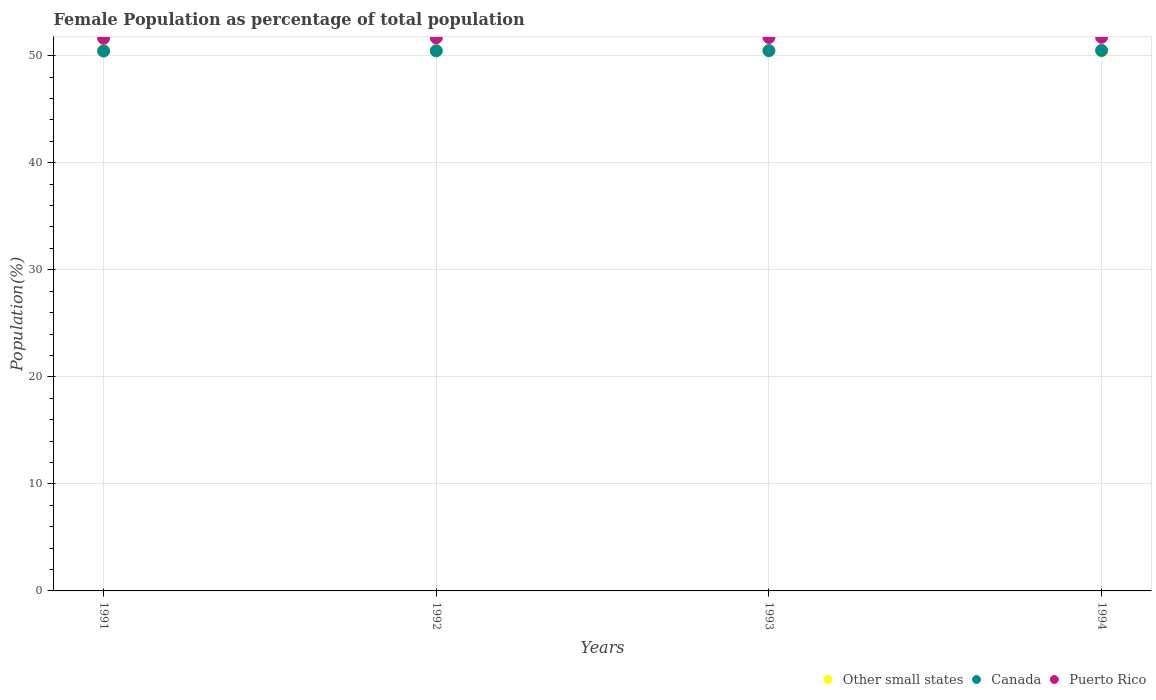How many different coloured dotlines are there?
Provide a short and direct response. 3. What is the female population in in Canada in 1994?
Your response must be concise. 50.49. Across all years, what is the maximum female population in in Canada?
Make the answer very short. 50.49. Across all years, what is the minimum female population in in Puerto Rico?
Your response must be concise. 51.63. In which year was the female population in in Puerto Rico maximum?
Your answer should be compact. 1994. In which year was the female population in in Puerto Rico minimum?
Ensure brevity in your answer.  1991. What is the total female population in in Other small states in the graph?
Provide a succinct answer. 201.91. What is the difference between the female population in in Other small states in 1991 and that in 1992?
Your response must be concise. 0.03. What is the difference between the female population in in Puerto Rico in 1993 and the female population in in Canada in 1991?
Give a very brief answer. 1.27. What is the average female population in in Canada per year?
Your response must be concise. 50.46. In the year 1991, what is the difference between the female population in in Canada and female population in in Other small states?
Offer a very short reply. -0.08. In how many years, is the female population in in Other small states greater than 38 %?
Your response must be concise. 4. What is the ratio of the female population in in Puerto Rico in 1992 to that in 1993?
Make the answer very short. 1. What is the difference between the highest and the second highest female population in in Other small states?
Offer a terse response. 0.03. What is the difference between the highest and the lowest female population in in Other small states?
Ensure brevity in your answer.  0.08. Is the sum of the female population in in Puerto Rico in 1991 and 1994 greater than the maximum female population in in Other small states across all years?
Your answer should be compact. Yes. Is the female population in in Other small states strictly greater than the female population in in Canada over the years?
Ensure brevity in your answer.  No. How many years are there in the graph?
Your response must be concise. 4. What is the difference between two consecutive major ticks on the Y-axis?
Offer a terse response. 10. Are the values on the major ticks of Y-axis written in scientific E-notation?
Your answer should be very brief. No. Does the graph contain any zero values?
Provide a succinct answer. No. How many legend labels are there?
Offer a terse response. 3. What is the title of the graph?
Your answer should be very brief. Female Population as percentage of total population. What is the label or title of the X-axis?
Give a very brief answer. Years. What is the label or title of the Y-axis?
Offer a terse response. Population(%). What is the Population(%) in Other small states in 1991?
Offer a very short reply. 50.52. What is the Population(%) of Canada in 1991?
Keep it short and to the point. 50.44. What is the Population(%) of Puerto Rico in 1991?
Make the answer very short. 51.63. What is the Population(%) in Other small states in 1992?
Your answer should be compact. 50.49. What is the Population(%) in Canada in 1992?
Your response must be concise. 50.46. What is the Population(%) in Puerto Rico in 1992?
Offer a terse response. 51.67. What is the Population(%) in Other small states in 1993?
Keep it short and to the point. 50.46. What is the Population(%) of Canada in 1993?
Keep it short and to the point. 50.48. What is the Population(%) in Puerto Rico in 1993?
Provide a short and direct response. 51.7. What is the Population(%) of Other small states in 1994?
Your answer should be compact. 50.44. What is the Population(%) in Canada in 1994?
Provide a succinct answer. 50.49. What is the Population(%) of Puerto Rico in 1994?
Your response must be concise. 51.72. Across all years, what is the maximum Population(%) in Other small states?
Give a very brief answer. 50.52. Across all years, what is the maximum Population(%) in Canada?
Your answer should be compact. 50.49. Across all years, what is the maximum Population(%) of Puerto Rico?
Give a very brief answer. 51.72. Across all years, what is the minimum Population(%) of Other small states?
Offer a very short reply. 50.44. Across all years, what is the minimum Population(%) in Canada?
Provide a short and direct response. 50.44. Across all years, what is the minimum Population(%) in Puerto Rico?
Your response must be concise. 51.63. What is the total Population(%) in Other small states in the graph?
Make the answer very short. 201.91. What is the total Population(%) of Canada in the graph?
Offer a very short reply. 201.86. What is the total Population(%) of Puerto Rico in the graph?
Your answer should be very brief. 206.73. What is the difference between the Population(%) of Other small states in 1991 and that in 1992?
Give a very brief answer. 0.03. What is the difference between the Population(%) in Canada in 1991 and that in 1992?
Your answer should be very brief. -0.02. What is the difference between the Population(%) in Puerto Rico in 1991 and that in 1992?
Provide a succinct answer. -0.04. What is the difference between the Population(%) of Other small states in 1991 and that in 1993?
Your answer should be compact. 0.06. What is the difference between the Population(%) in Canada in 1991 and that in 1993?
Your answer should be compact. -0.04. What is the difference between the Population(%) of Puerto Rico in 1991 and that in 1993?
Make the answer very short. -0.07. What is the difference between the Population(%) of Other small states in 1991 and that in 1994?
Your response must be concise. 0.08. What is the difference between the Population(%) in Canada in 1991 and that in 1994?
Provide a short and direct response. -0.06. What is the difference between the Population(%) in Puerto Rico in 1991 and that in 1994?
Offer a very short reply. -0.09. What is the difference between the Population(%) of Other small states in 1992 and that in 1993?
Provide a succinct answer. 0.03. What is the difference between the Population(%) of Canada in 1992 and that in 1993?
Your response must be concise. -0.02. What is the difference between the Population(%) in Puerto Rico in 1992 and that in 1993?
Your answer should be compact. -0.03. What is the difference between the Population(%) of Other small states in 1992 and that in 1994?
Your answer should be very brief. 0.04. What is the difference between the Population(%) of Canada in 1992 and that in 1994?
Give a very brief answer. -0.04. What is the difference between the Population(%) in Puerto Rico in 1992 and that in 1994?
Make the answer very short. -0.05. What is the difference between the Population(%) of Other small states in 1993 and that in 1994?
Your response must be concise. 0.02. What is the difference between the Population(%) of Canada in 1993 and that in 1994?
Offer a very short reply. -0.02. What is the difference between the Population(%) in Puerto Rico in 1993 and that in 1994?
Provide a short and direct response. -0.02. What is the difference between the Population(%) of Other small states in 1991 and the Population(%) of Canada in 1992?
Ensure brevity in your answer.  0.06. What is the difference between the Population(%) of Other small states in 1991 and the Population(%) of Puerto Rico in 1992?
Make the answer very short. -1.15. What is the difference between the Population(%) of Canada in 1991 and the Population(%) of Puerto Rico in 1992?
Make the answer very short. -1.24. What is the difference between the Population(%) in Other small states in 1991 and the Population(%) in Canada in 1993?
Offer a very short reply. 0.04. What is the difference between the Population(%) in Other small states in 1991 and the Population(%) in Puerto Rico in 1993?
Offer a very short reply. -1.18. What is the difference between the Population(%) of Canada in 1991 and the Population(%) of Puerto Rico in 1993?
Your answer should be very brief. -1.27. What is the difference between the Population(%) of Other small states in 1991 and the Population(%) of Canada in 1994?
Make the answer very short. 0.03. What is the difference between the Population(%) in Other small states in 1991 and the Population(%) in Puerto Rico in 1994?
Provide a short and direct response. -1.2. What is the difference between the Population(%) of Canada in 1991 and the Population(%) of Puerto Rico in 1994?
Provide a short and direct response. -1.29. What is the difference between the Population(%) of Other small states in 1992 and the Population(%) of Canada in 1993?
Offer a terse response. 0.01. What is the difference between the Population(%) in Other small states in 1992 and the Population(%) in Puerto Rico in 1993?
Ensure brevity in your answer.  -1.21. What is the difference between the Population(%) of Canada in 1992 and the Population(%) of Puerto Rico in 1993?
Ensure brevity in your answer.  -1.25. What is the difference between the Population(%) of Other small states in 1992 and the Population(%) of Canada in 1994?
Provide a succinct answer. -0.01. What is the difference between the Population(%) of Other small states in 1992 and the Population(%) of Puerto Rico in 1994?
Offer a terse response. -1.24. What is the difference between the Population(%) in Canada in 1992 and the Population(%) in Puerto Rico in 1994?
Your answer should be very brief. -1.27. What is the difference between the Population(%) in Other small states in 1993 and the Population(%) in Canada in 1994?
Your answer should be very brief. -0.03. What is the difference between the Population(%) in Other small states in 1993 and the Population(%) in Puerto Rico in 1994?
Make the answer very short. -1.26. What is the difference between the Population(%) of Canada in 1993 and the Population(%) of Puerto Rico in 1994?
Make the answer very short. -1.25. What is the average Population(%) in Other small states per year?
Give a very brief answer. 50.48. What is the average Population(%) of Canada per year?
Your response must be concise. 50.46. What is the average Population(%) of Puerto Rico per year?
Offer a very short reply. 51.68. In the year 1991, what is the difference between the Population(%) in Other small states and Population(%) in Canada?
Offer a terse response. 0.08. In the year 1991, what is the difference between the Population(%) of Other small states and Population(%) of Puerto Rico?
Offer a terse response. -1.11. In the year 1991, what is the difference between the Population(%) in Canada and Population(%) in Puerto Rico?
Provide a succinct answer. -1.2. In the year 1992, what is the difference between the Population(%) in Other small states and Population(%) in Canada?
Provide a succinct answer. 0.03. In the year 1992, what is the difference between the Population(%) of Other small states and Population(%) of Puerto Rico?
Provide a succinct answer. -1.19. In the year 1992, what is the difference between the Population(%) in Canada and Population(%) in Puerto Rico?
Your answer should be very brief. -1.22. In the year 1993, what is the difference between the Population(%) of Other small states and Population(%) of Canada?
Make the answer very short. -0.01. In the year 1993, what is the difference between the Population(%) in Other small states and Population(%) in Puerto Rico?
Provide a succinct answer. -1.24. In the year 1993, what is the difference between the Population(%) in Canada and Population(%) in Puerto Rico?
Provide a short and direct response. -1.23. In the year 1994, what is the difference between the Population(%) of Other small states and Population(%) of Canada?
Your answer should be compact. -0.05. In the year 1994, what is the difference between the Population(%) in Other small states and Population(%) in Puerto Rico?
Your answer should be compact. -1.28. In the year 1994, what is the difference between the Population(%) of Canada and Population(%) of Puerto Rico?
Your answer should be compact. -1.23. What is the ratio of the Population(%) in Other small states in 1991 to that in 1992?
Your answer should be very brief. 1. What is the ratio of the Population(%) of Canada in 1991 to that in 1993?
Your response must be concise. 1. What is the ratio of the Population(%) in Other small states in 1991 to that in 1994?
Your response must be concise. 1. What is the ratio of the Population(%) in Canada in 1992 to that in 1994?
Ensure brevity in your answer.  1. What is the ratio of the Population(%) in Other small states in 1993 to that in 1994?
Provide a succinct answer. 1. What is the ratio of the Population(%) in Canada in 1993 to that in 1994?
Give a very brief answer. 1. What is the difference between the highest and the second highest Population(%) in Other small states?
Give a very brief answer. 0.03. What is the difference between the highest and the second highest Population(%) of Canada?
Your answer should be compact. 0.02. What is the difference between the highest and the second highest Population(%) of Puerto Rico?
Provide a succinct answer. 0.02. What is the difference between the highest and the lowest Population(%) of Other small states?
Your answer should be compact. 0.08. What is the difference between the highest and the lowest Population(%) in Canada?
Your answer should be compact. 0.06. What is the difference between the highest and the lowest Population(%) of Puerto Rico?
Keep it short and to the point. 0.09. 